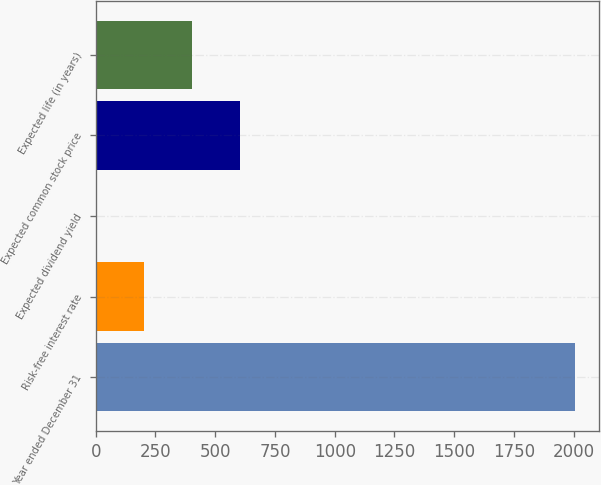Convert chart. <chart><loc_0><loc_0><loc_500><loc_500><bar_chart><fcel>Year ended December 31<fcel>Risk-free interest rate<fcel>Expected dividend yield<fcel>Expected common stock price<fcel>Expected life (in years)<nl><fcel>2007<fcel>203.56<fcel>3.18<fcel>604.32<fcel>403.94<nl></chart> 